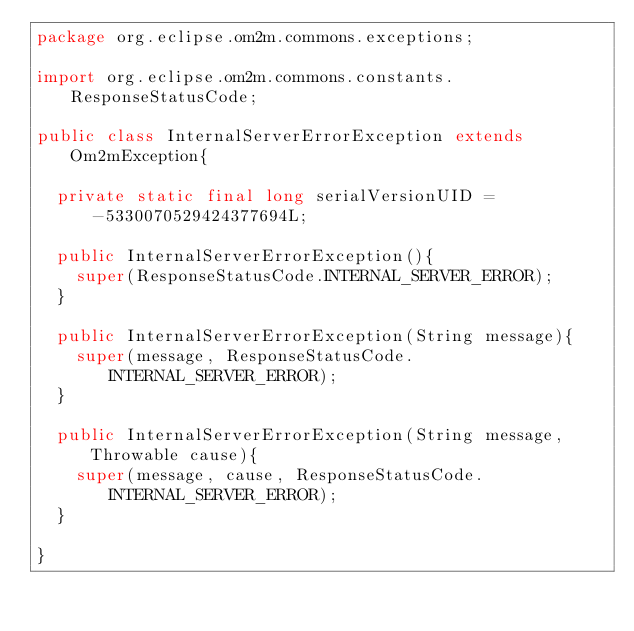Convert code to text. <code><loc_0><loc_0><loc_500><loc_500><_Java_>package org.eclipse.om2m.commons.exceptions;

import org.eclipse.om2m.commons.constants.ResponseStatusCode;

public class InternalServerErrorException extends Om2mException{

	private static final long serialVersionUID = -5330070529424377694L;
	
	public InternalServerErrorException(){
		super(ResponseStatusCode.INTERNAL_SERVER_ERROR);
	}
	
	public InternalServerErrorException(String message){
		super(message, ResponseStatusCode.INTERNAL_SERVER_ERROR);
	}
	
	public InternalServerErrorException(String message, Throwable cause){
		super(message, cause, ResponseStatusCode.INTERNAL_SERVER_ERROR);
	}
	
}
</code> 